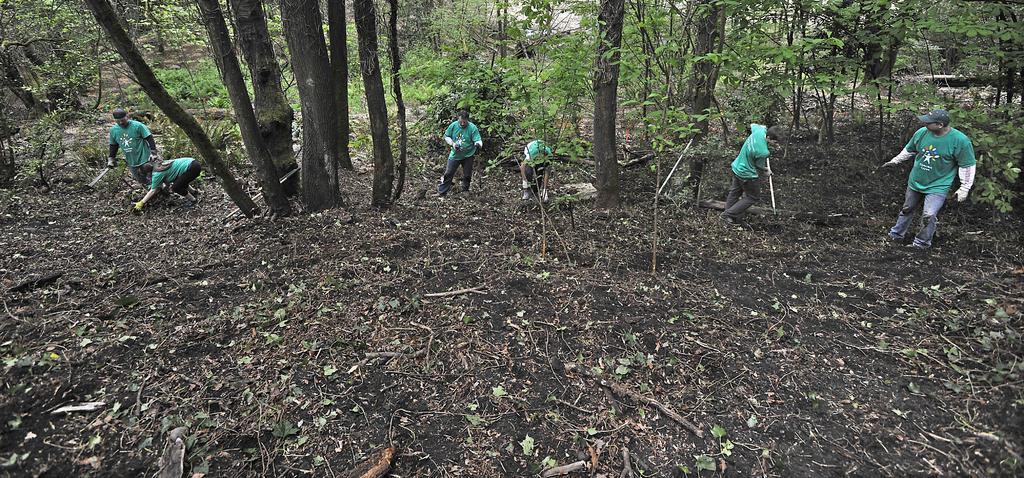How would you summarize this image in a sentence or two? In this image there are few persons are standing on the land having few plants and trees. They are wearing green T-shirts. Few persons are holding sticks in their hands. Right side person is wearing a cap. 